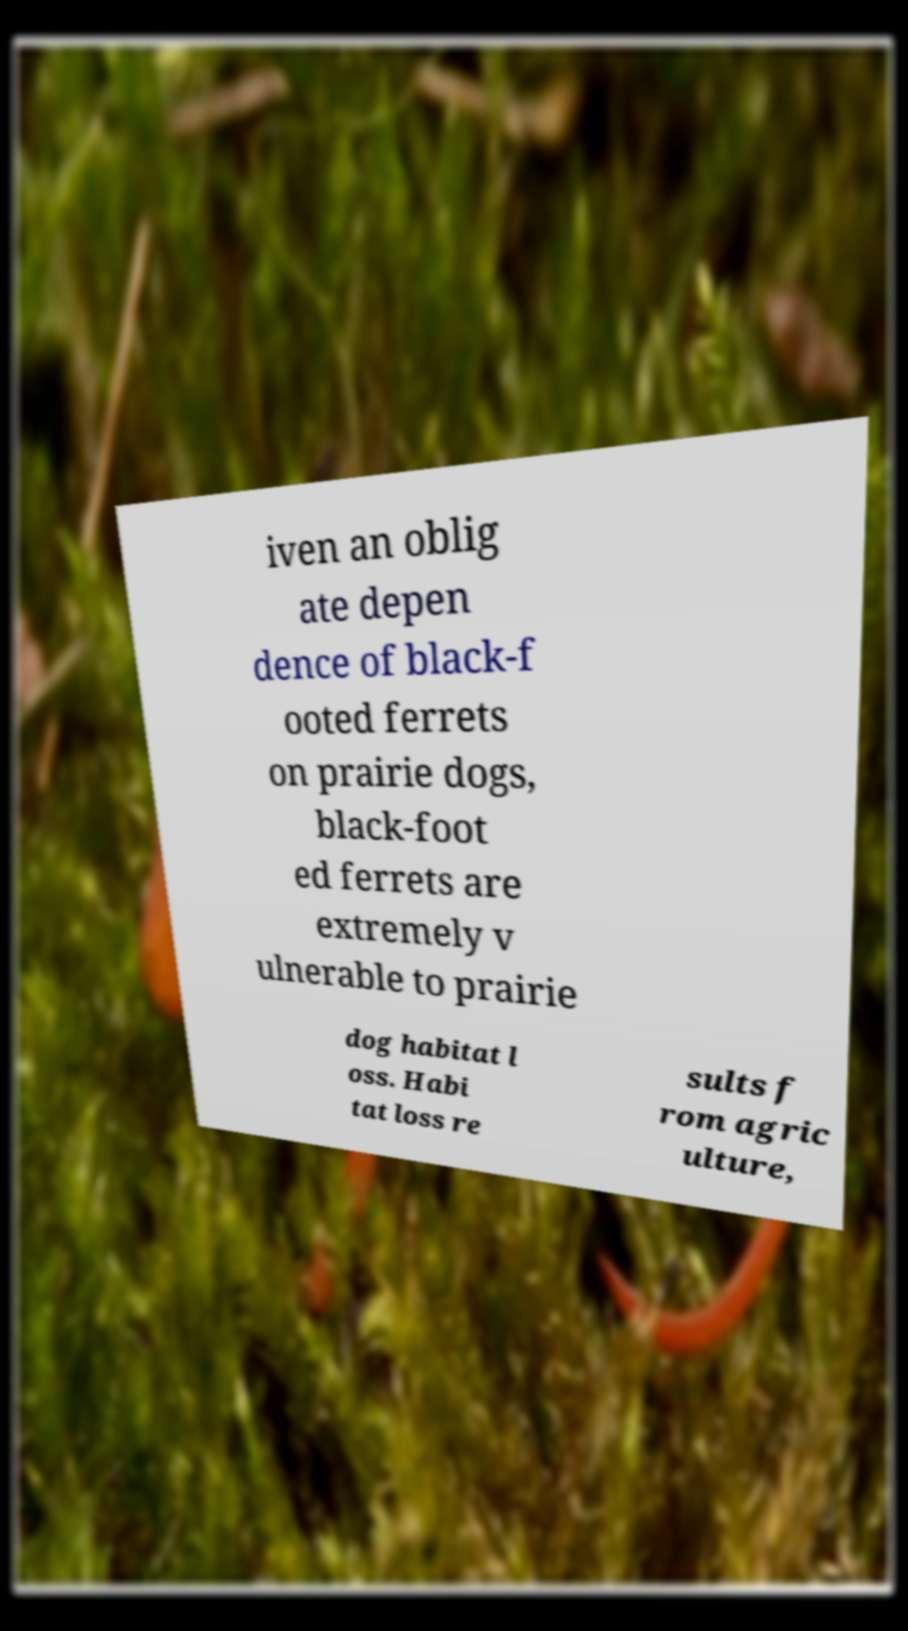Can you accurately transcribe the text from the provided image for me? iven an oblig ate depen dence of black-f ooted ferrets on prairie dogs, black-foot ed ferrets are extremely v ulnerable to prairie dog habitat l oss. Habi tat loss re sults f rom agric ulture, 